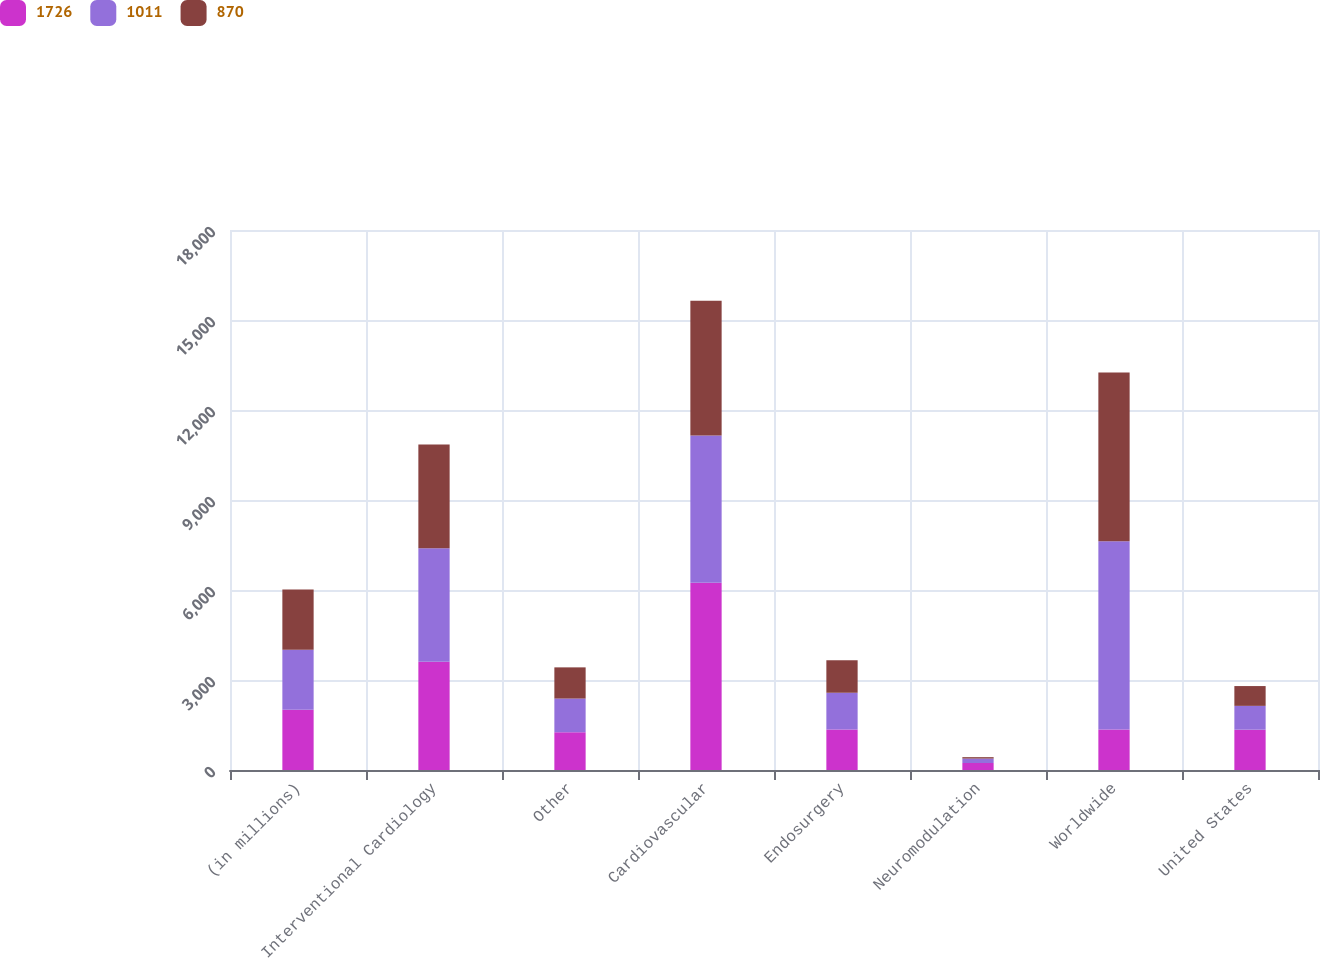<chart> <loc_0><loc_0><loc_500><loc_500><stacked_bar_chart><ecel><fcel>(in millions)<fcel>Interventional Cardiology<fcel>Other<fcel>Cardiovascular<fcel>Endosurgery<fcel>Neuromodulation<fcel>Worldwide<fcel>United States<nl><fcel>1726<fcel>2006<fcel>3612<fcel>1258<fcel>6241<fcel>1346<fcel>234<fcel>1346<fcel>1343<nl><fcel>1011<fcel>2005<fcel>3783<fcel>1124<fcel>4907<fcel>1228<fcel>148<fcel>6283<fcel>795<nl><fcel>870<fcel>2004<fcel>3451<fcel>1039<fcel>4490<fcel>1088<fcel>46<fcel>5624<fcel>660<nl></chart> 